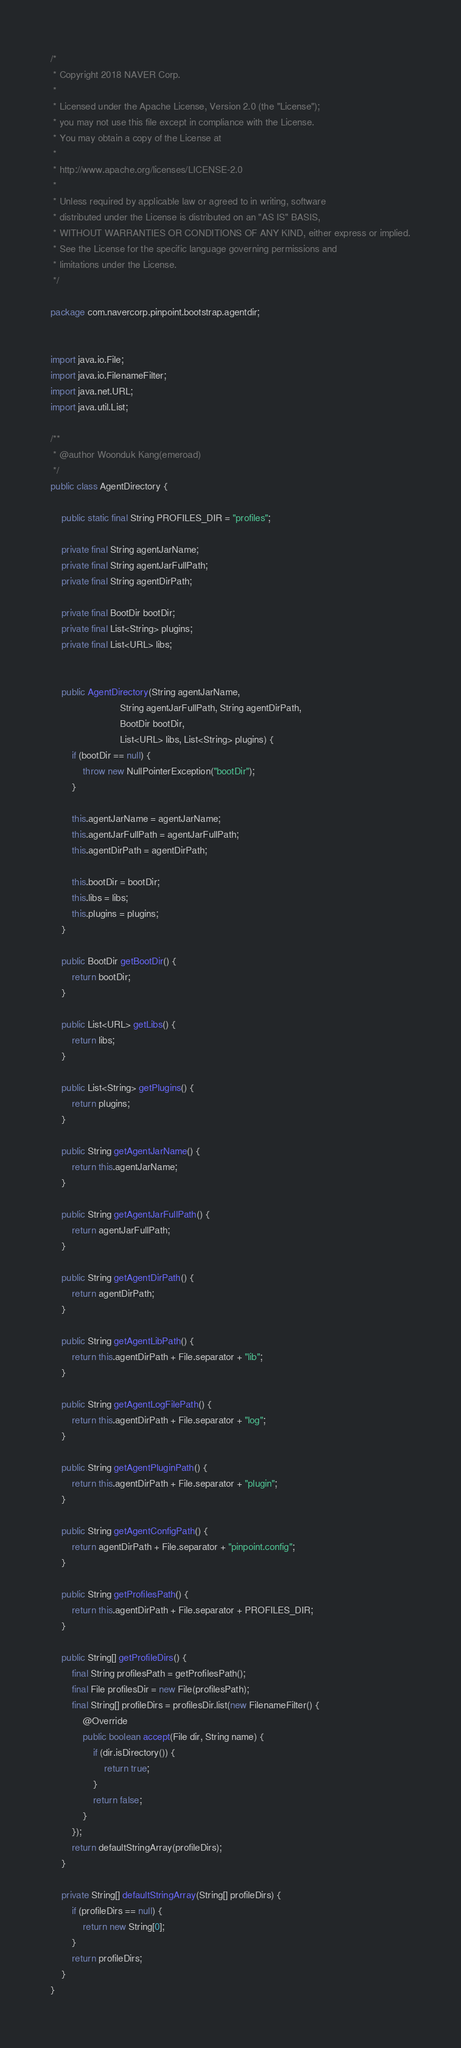<code> <loc_0><loc_0><loc_500><loc_500><_Java_>/*
 * Copyright 2018 NAVER Corp.
 *
 * Licensed under the Apache License, Version 2.0 (the "License");
 * you may not use this file except in compliance with the License.
 * You may obtain a copy of the License at
 *
 * http://www.apache.org/licenses/LICENSE-2.0
 *
 * Unless required by applicable law or agreed to in writing, software
 * distributed under the License is distributed on an "AS IS" BASIS,
 * WITHOUT WARRANTIES OR CONDITIONS OF ANY KIND, either express or implied.
 * See the License for the specific language governing permissions and
 * limitations under the License.
 */

package com.navercorp.pinpoint.bootstrap.agentdir;


import java.io.File;
import java.io.FilenameFilter;
import java.net.URL;
import java.util.List;

/**
 * @author Woonduk Kang(emeroad)
 */
public class AgentDirectory {

    public static final String PROFILES_DIR = "profiles";

    private final String agentJarName;
    private final String agentJarFullPath;
    private final String agentDirPath;

    private final BootDir bootDir;
    private final List<String> plugins;
    private final List<URL> libs;


    public AgentDirectory(String agentJarName,
                          String agentJarFullPath, String agentDirPath,
                          BootDir bootDir,
                          List<URL> libs, List<String> plugins) {
        if (bootDir == null) {
            throw new NullPointerException("bootDir");
        }

        this.agentJarName = agentJarName;
        this.agentJarFullPath = agentJarFullPath;
        this.agentDirPath = agentDirPath;

        this.bootDir = bootDir;
        this.libs = libs;
        this.plugins = plugins;
    }

    public BootDir getBootDir() {
        return bootDir;
    }

    public List<URL> getLibs() {
        return libs;
    }

    public List<String> getPlugins() {
        return plugins;
    }

    public String getAgentJarName() {
        return this.agentJarName;
    }

    public String getAgentJarFullPath() {
        return agentJarFullPath;
    }

    public String getAgentDirPath() {
        return agentDirPath;
    }

    public String getAgentLibPath() {
        return this.agentDirPath + File.separator + "lib";
    }

    public String getAgentLogFilePath() {
        return this.agentDirPath + File.separator + "log";
    }

    public String getAgentPluginPath() {
        return this.agentDirPath + File.separator + "plugin";
    }

    public String getAgentConfigPath() {
        return agentDirPath + File.separator + "pinpoint.config";
    }

    public String getProfilesPath() {
        return this.agentDirPath + File.separator + PROFILES_DIR;
    }

    public String[] getProfileDirs() {
        final String profilesPath = getProfilesPath();
        final File profilesDir = new File(profilesPath);
        final String[] profileDirs = profilesDir.list(new FilenameFilter() {
            @Override
            public boolean accept(File dir, String name) {
                if (dir.isDirectory()) {
                    return true;
                }
                return false;
            }
        });
        return defaultStringArray(profileDirs);
    }

    private String[] defaultStringArray(String[] profileDirs) {
        if (profileDirs == null) {
            return new String[0];
        }
        return profileDirs;
    }
}
</code> 